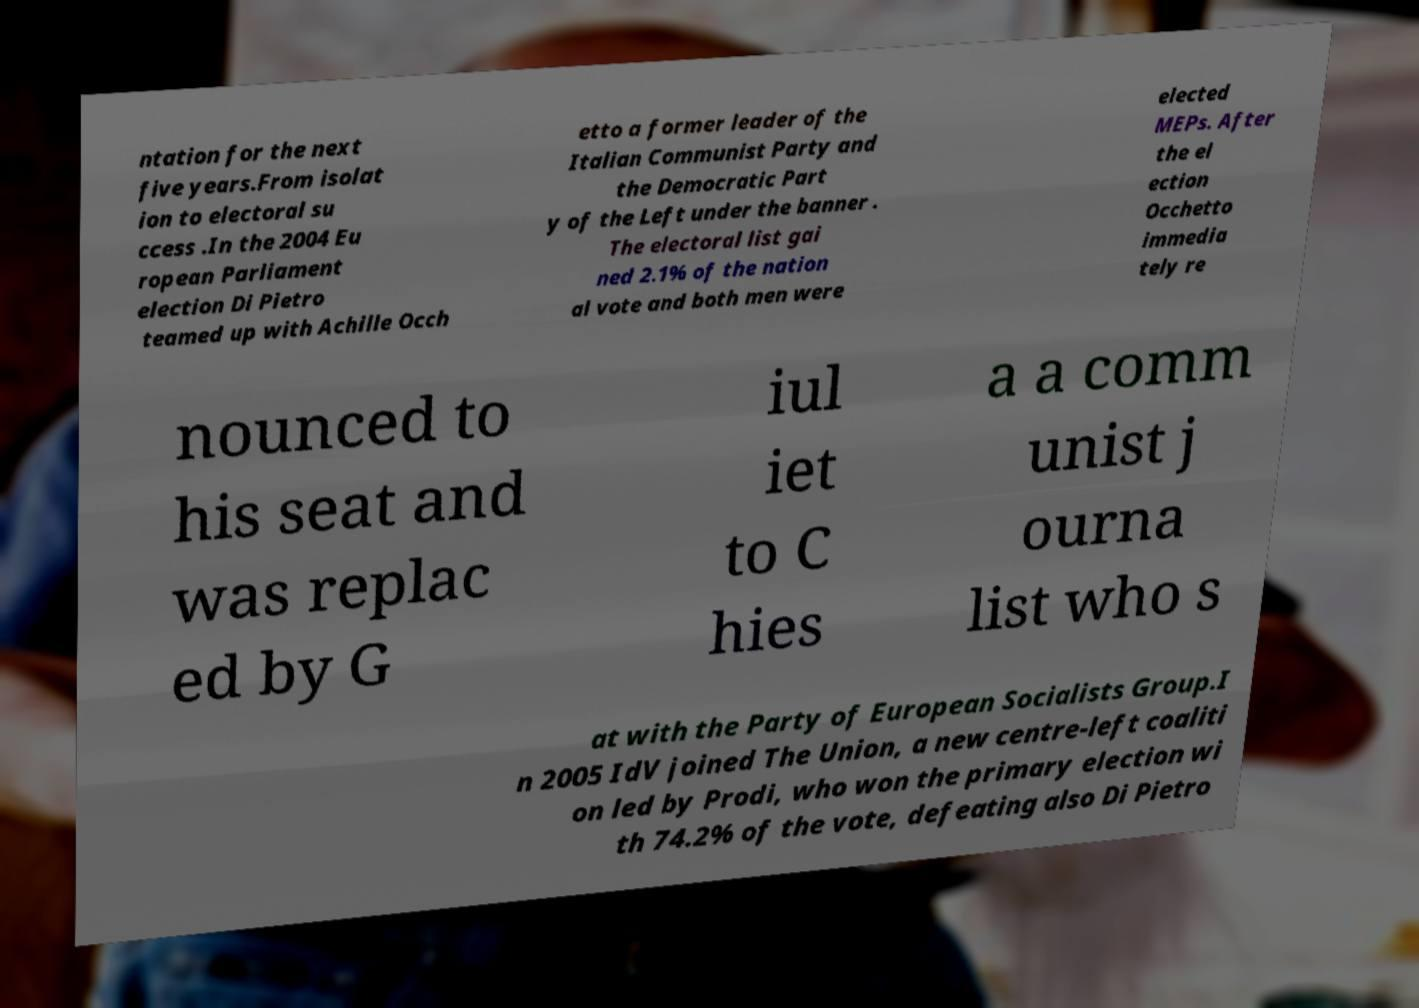Please identify and transcribe the text found in this image. ntation for the next five years.From isolat ion to electoral su ccess .In the 2004 Eu ropean Parliament election Di Pietro teamed up with Achille Occh etto a former leader of the Italian Communist Party and the Democratic Part y of the Left under the banner . The electoral list gai ned 2.1% of the nation al vote and both men were elected MEPs. After the el ection Occhetto immedia tely re nounced to his seat and was replac ed by G iul iet to C hies a a comm unist j ourna list who s at with the Party of European Socialists Group.I n 2005 IdV joined The Union, a new centre-left coaliti on led by Prodi, who won the primary election wi th 74.2% of the vote, defeating also Di Pietro 